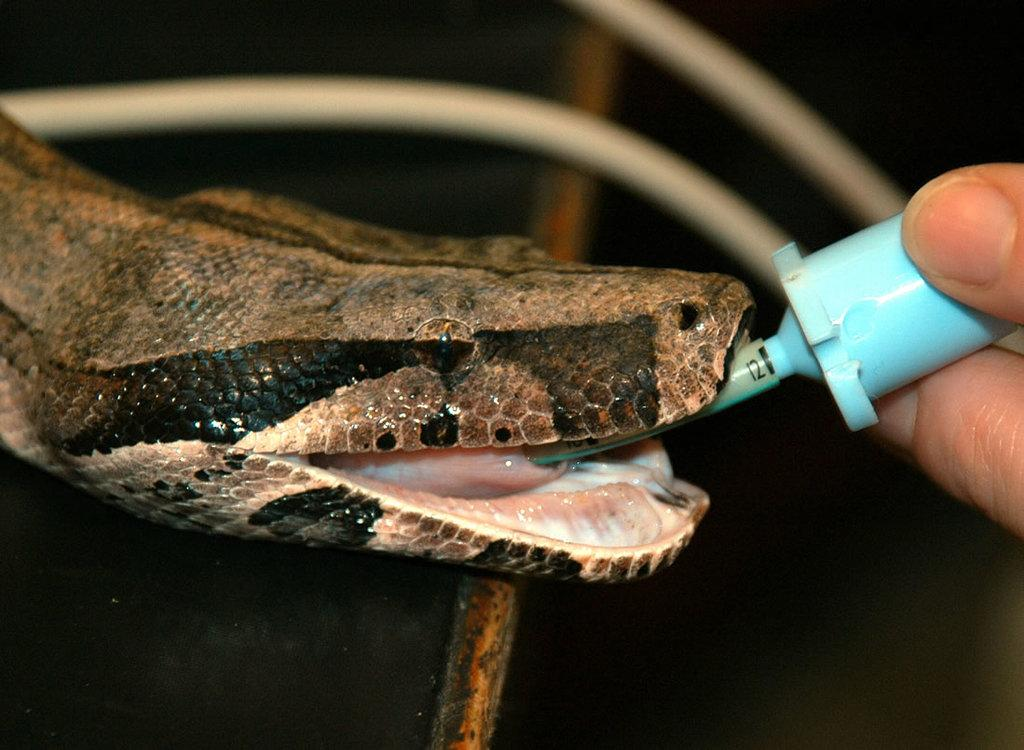What animal is present in the image? There is a snake in the image. What can be seen on the right side of the image? There are fingers holding an object on the right side of the image. Can you describe the background of the image? The background of the image is blurred. How many eggs are on the shelf in the image? There is no shelf or eggs present in the image. 